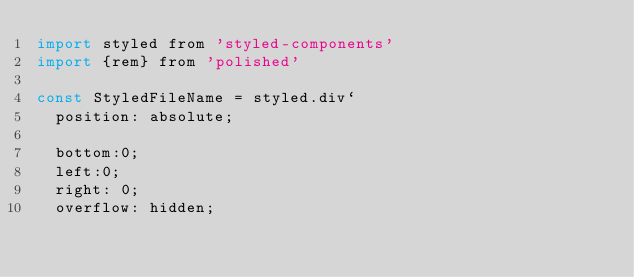<code> <loc_0><loc_0><loc_500><loc_500><_JavaScript_>import styled from 'styled-components'
import {rem} from 'polished'

const StyledFileName = styled.div`
	position: absolute;

	bottom:0;
	left:0;
	right: 0;
	overflow: hidden;</code> 